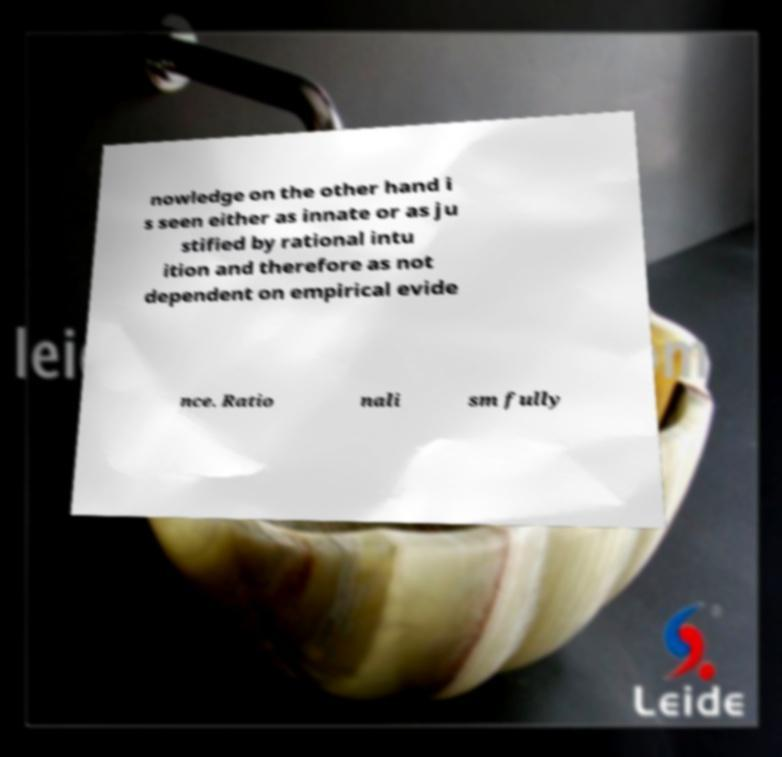I need the written content from this picture converted into text. Can you do that? nowledge on the other hand i s seen either as innate or as ju stified by rational intu ition and therefore as not dependent on empirical evide nce. Ratio nali sm fully 